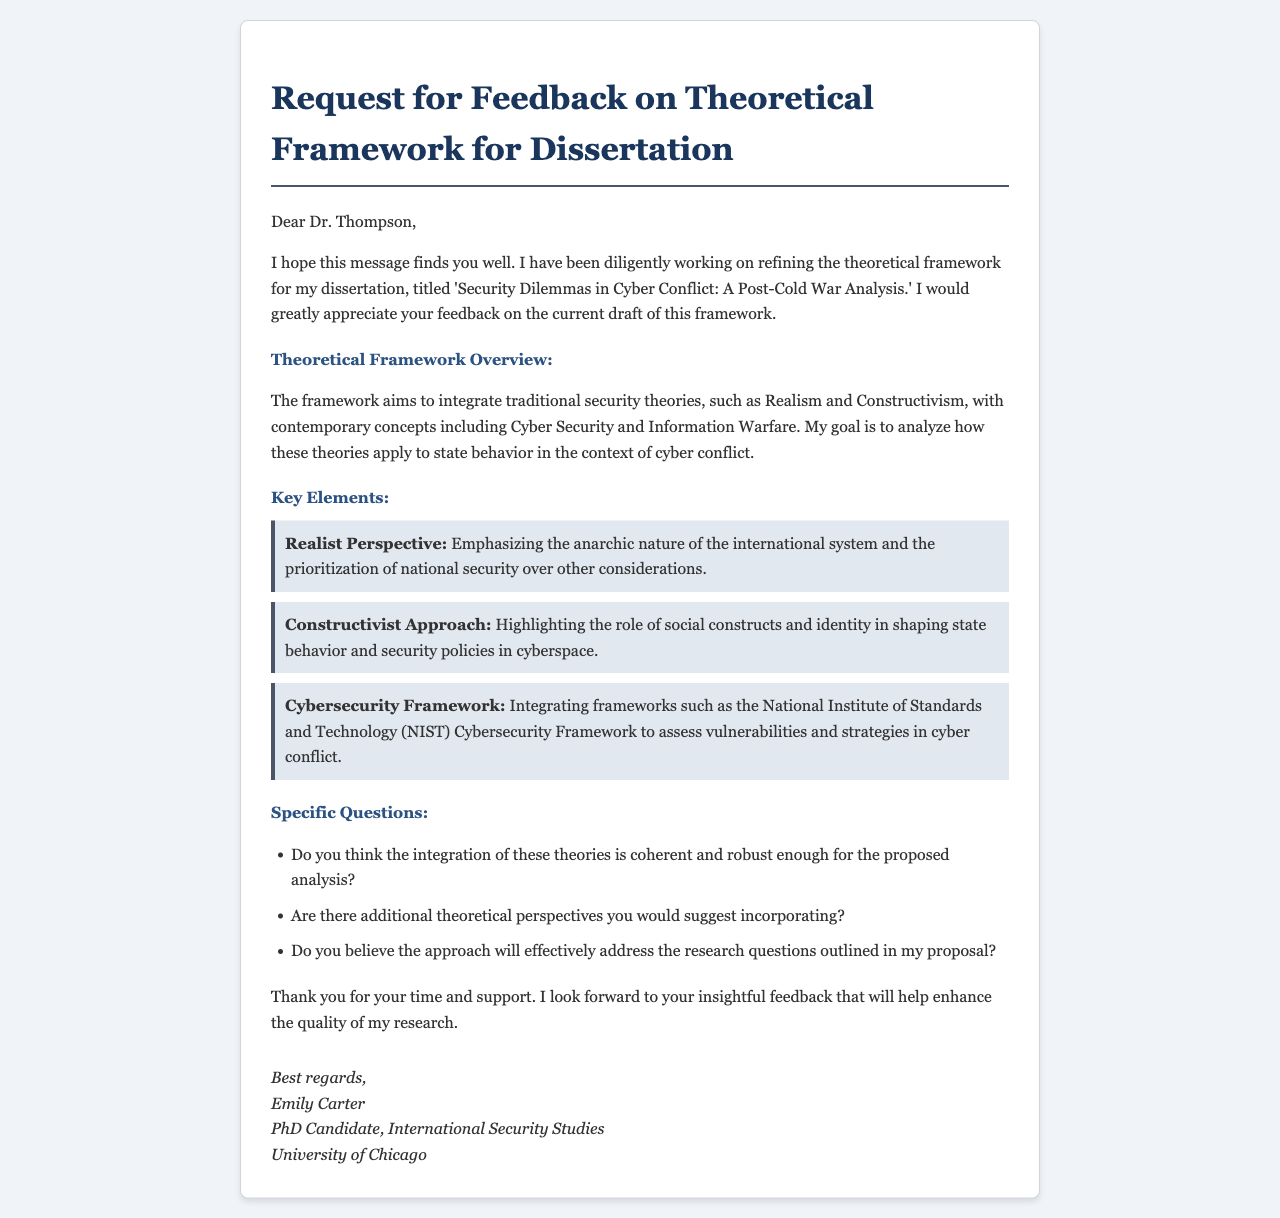What is the title of the dissertation? The title of the dissertation is provided in the email, which is 'Security Dilemmas in Cyber Conflict: A Post-Cold War Analysis.'
Answer: Security Dilemmas in Cyber Conflict: A Post-Cold War Analysis Who is the recipient of the email? The email addresses Dr. Thompson directly in the salutation, indicating he is the recipient.
Answer: Dr. Thompson What are the three key elements mentioned in the theoretical framework? The key elements are listed in the document as Realist Perspective, Constructivist Approach, and Cybersecurity Framework.
Answer: Realist Perspective, Constructivist Approach, Cybersecurity Framework How many specific questions are posed to the advisor? The email lists three specific questions directed at the advisor concerning the theoretical framework.
Answer: Three What does the author hope to receive from Dr. Thompson? The author expresses a desire for insightful feedback that will enhance the quality of her research.
Answer: Feedback What is the primary goal of the theoretical framework according to the document? The primary goal is to analyze how traditional and contemporary security theories apply to state behavior in the context of cyber conflict.
Answer: Analyze state behavior in cyber conflict 